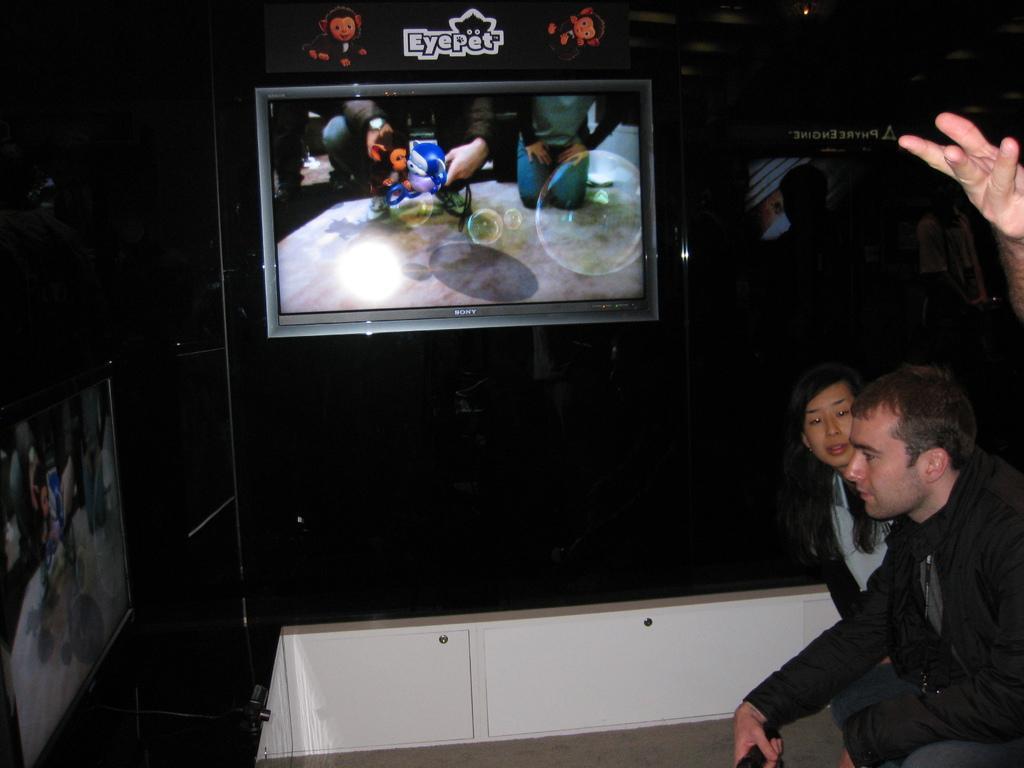Could you give a brief overview of what you see in this image? In this picture I can see a man and a woman and I can see a human hand on the right side. I can see couple of televisions and couple of boards with some text and I can see a person in the back and I can see dark background. 